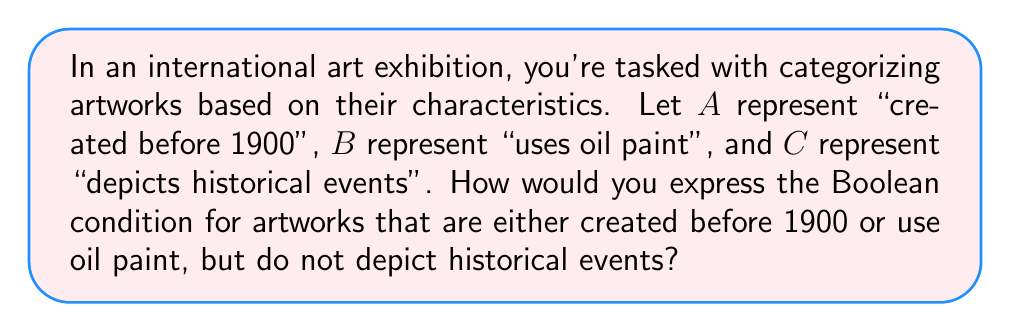Solve this math problem. To solve this problem, we need to construct a Boolean expression using the given variables and the specified conditions. Let's break it down step-by-step:

1. "Created before 1900" is represented by A
2. "Uses oil paint" is represented by B
3. "Depicts historical events" is represented by C

We want artworks that satisfy the following conditions:
- Either created before 1900 OR use oil paint: This is represented by $(A \lor B)$
- Do not depict historical events: This is represented by $\neg C$ (the negation of C)

To combine these conditions, we use the AND operator ($\land$) because we want both conditions to be true.

Therefore, the Boolean expression becomes:

$$(A \lor B) \land \neg C$$

This expression can be read as: "(A OR B) AND (NOT C)"

In the context of set theory, this would represent the intersection of the set of artworks that are either created before 1900 or use oil paint, with the set of artworks that do not depict historical events.
Answer: $(A \lor B) \land \neg C$ 